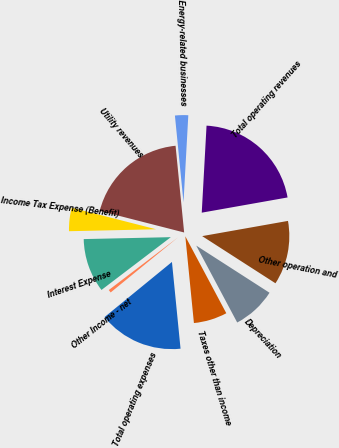<chart> <loc_0><loc_0><loc_500><loc_500><pie_chart><fcel>Utility revenues<fcel>Energy-related businesses<fcel>Total operating revenues<fcel>Other operation and<fcel>Depreciation<fcel>Taxes other than income<fcel>Total operating expenses<fcel>Other Income - net<fcel>Interest Expense<fcel>Income Tax Expense (Benefit)<nl><fcel>19.44%<fcel>2.45%<fcel>21.33%<fcel>11.89%<fcel>8.11%<fcel>6.22%<fcel>15.66%<fcel>0.56%<fcel>10.0%<fcel>4.34%<nl></chart> 